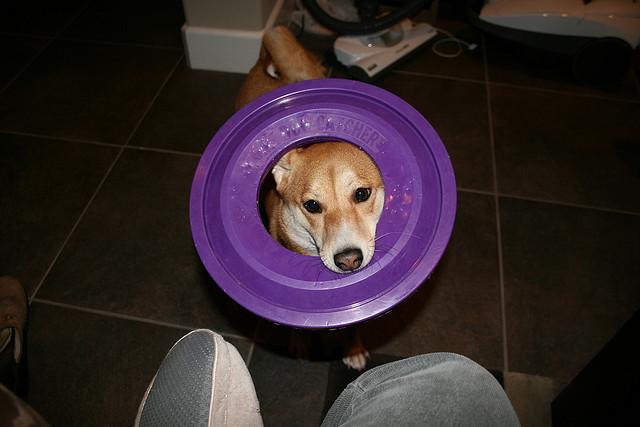Is the animal having  fun?
Answer briefly. Yes. What animal do these look like?
Short answer required. Dog. What is on the animal's head?
Keep it brief. Frisbee. What animal is shown?
Be succinct. Dog. 